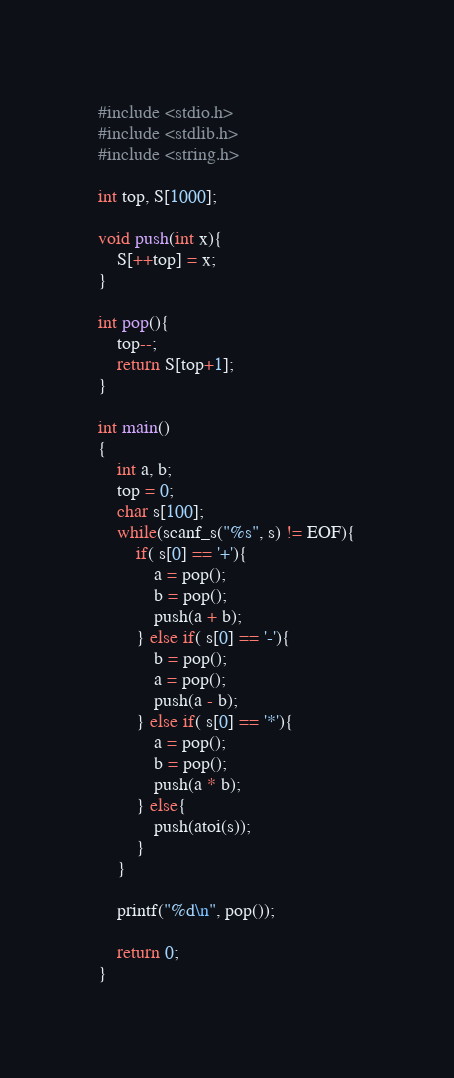Convert code to text. <code><loc_0><loc_0><loc_500><loc_500><_C_>#include <stdio.h>
#include <stdlib.h>
#include <string.h>

int top, S[1000];

void push(int x){
	S[++top] = x;
}

int pop(){
	top--;
	return S[top+1];
}

int main()
{
	int a, b;
	top = 0;
	char s[100];
	while(scanf_s("%s", s) != EOF){
		if( s[0] == '+'){
			a = pop();
			b = pop();
			push(a + b);
		} else if( s[0] == '-'){
			b = pop();
			a = pop();
			push(a - b);
		} else if( s[0] == '*'){
			a = pop();
			b = pop();
			push(a * b);
		} else{
			push(atoi(s));
		}
	}

	printf("%d\n", pop());

	return 0;
}
</code> 